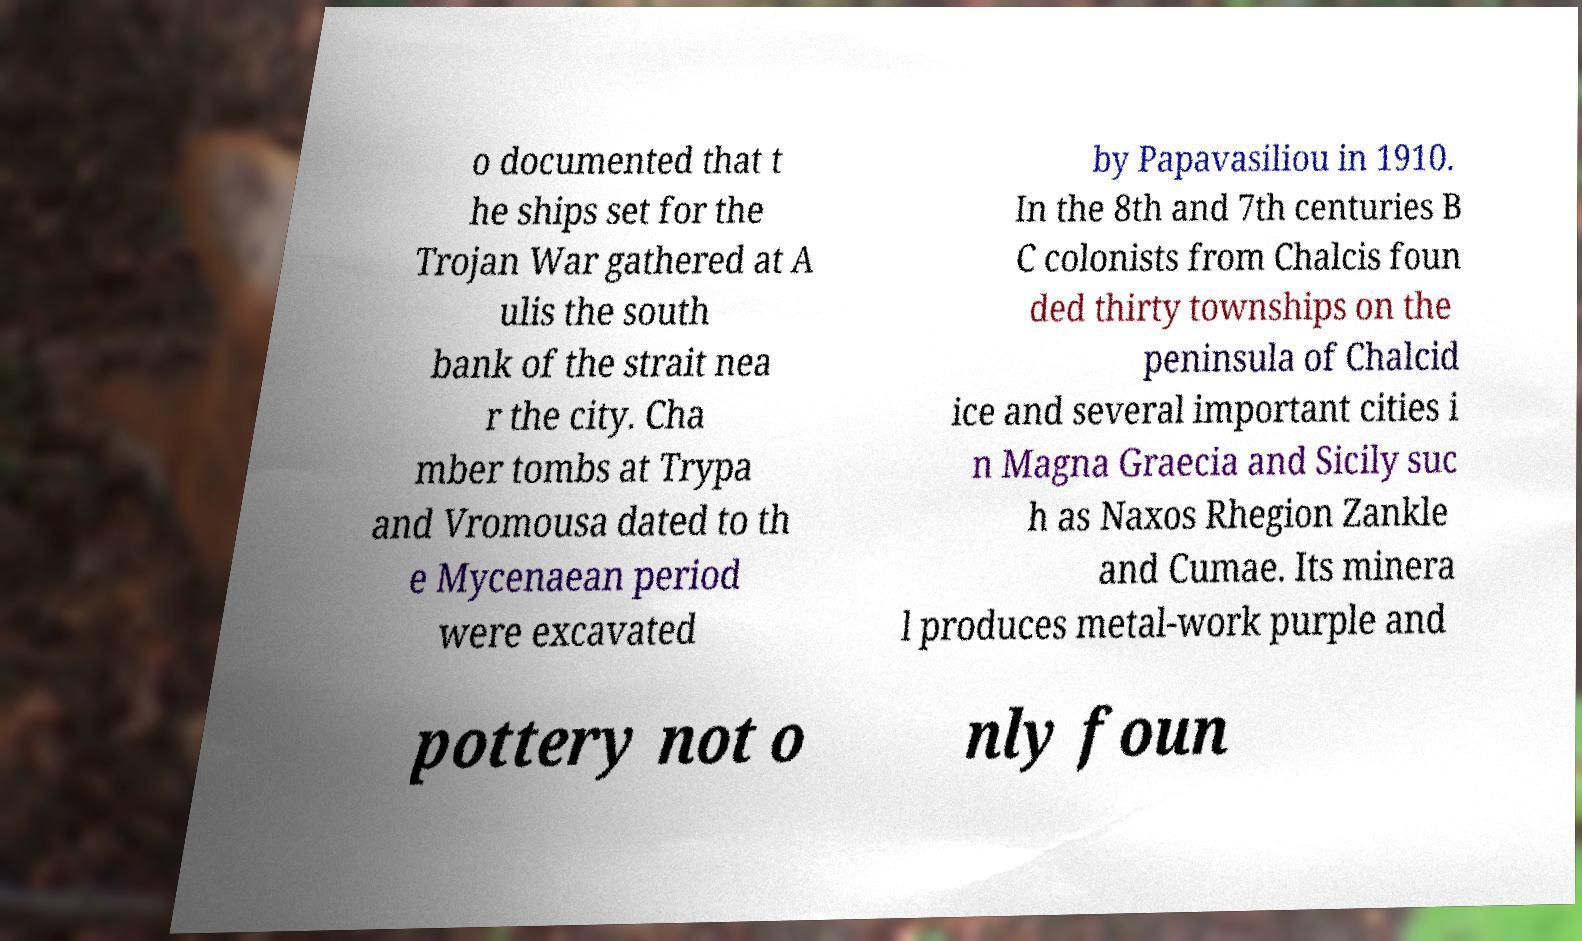Can you accurately transcribe the text from the provided image for me? o documented that t he ships set for the Trojan War gathered at A ulis the south bank of the strait nea r the city. Cha mber tombs at Trypa and Vromousa dated to th e Mycenaean period were excavated by Papavasiliou in 1910. In the 8th and 7th centuries B C colonists from Chalcis foun ded thirty townships on the peninsula of Chalcid ice and several important cities i n Magna Graecia and Sicily suc h as Naxos Rhegion Zankle and Cumae. Its minera l produces metal-work purple and pottery not o nly foun 